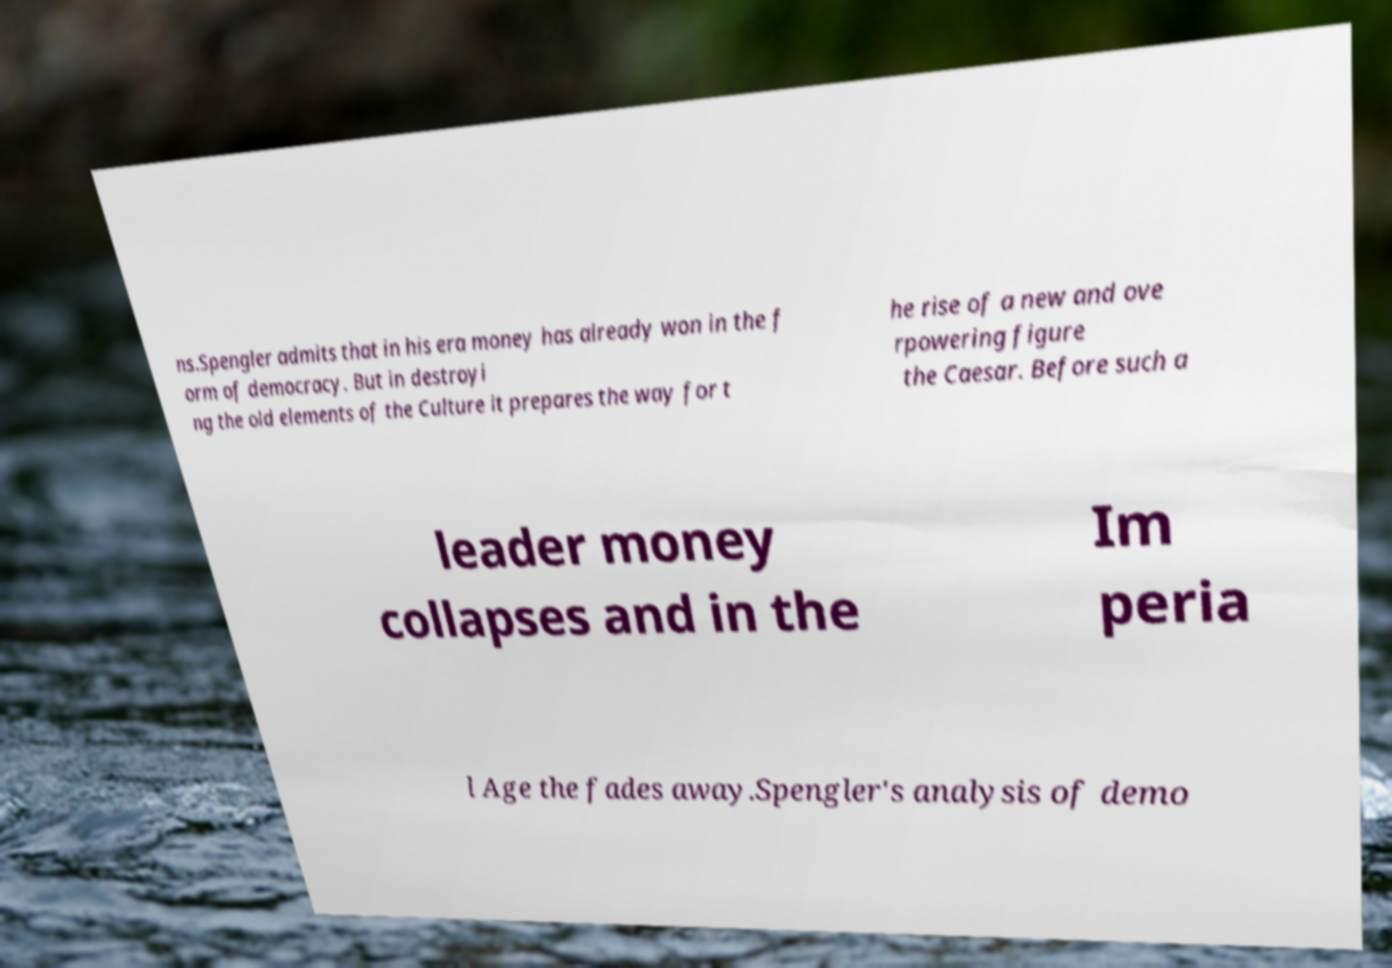There's text embedded in this image that I need extracted. Can you transcribe it verbatim? ns.Spengler admits that in his era money has already won in the f orm of democracy. But in destroyi ng the old elements of the Culture it prepares the way for t he rise of a new and ove rpowering figure the Caesar. Before such a leader money collapses and in the Im peria l Age the fades away.Spengler's analysis of demo 